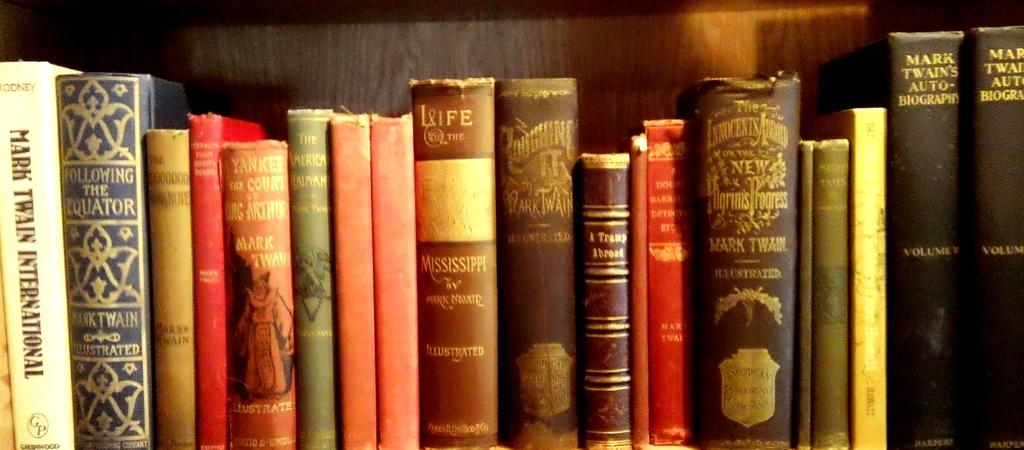What type of objects are visible in the image? There are books with text and images in the image. Can you describe the background of the image? There is a wooden wall in the background of the image. How many babies are visible in the image? There are no babies present in the image; it features books with text and images in front of a wooden wall. What type of fruit is being consumed by the person in the image? There is no person or fruit visible in the image. 